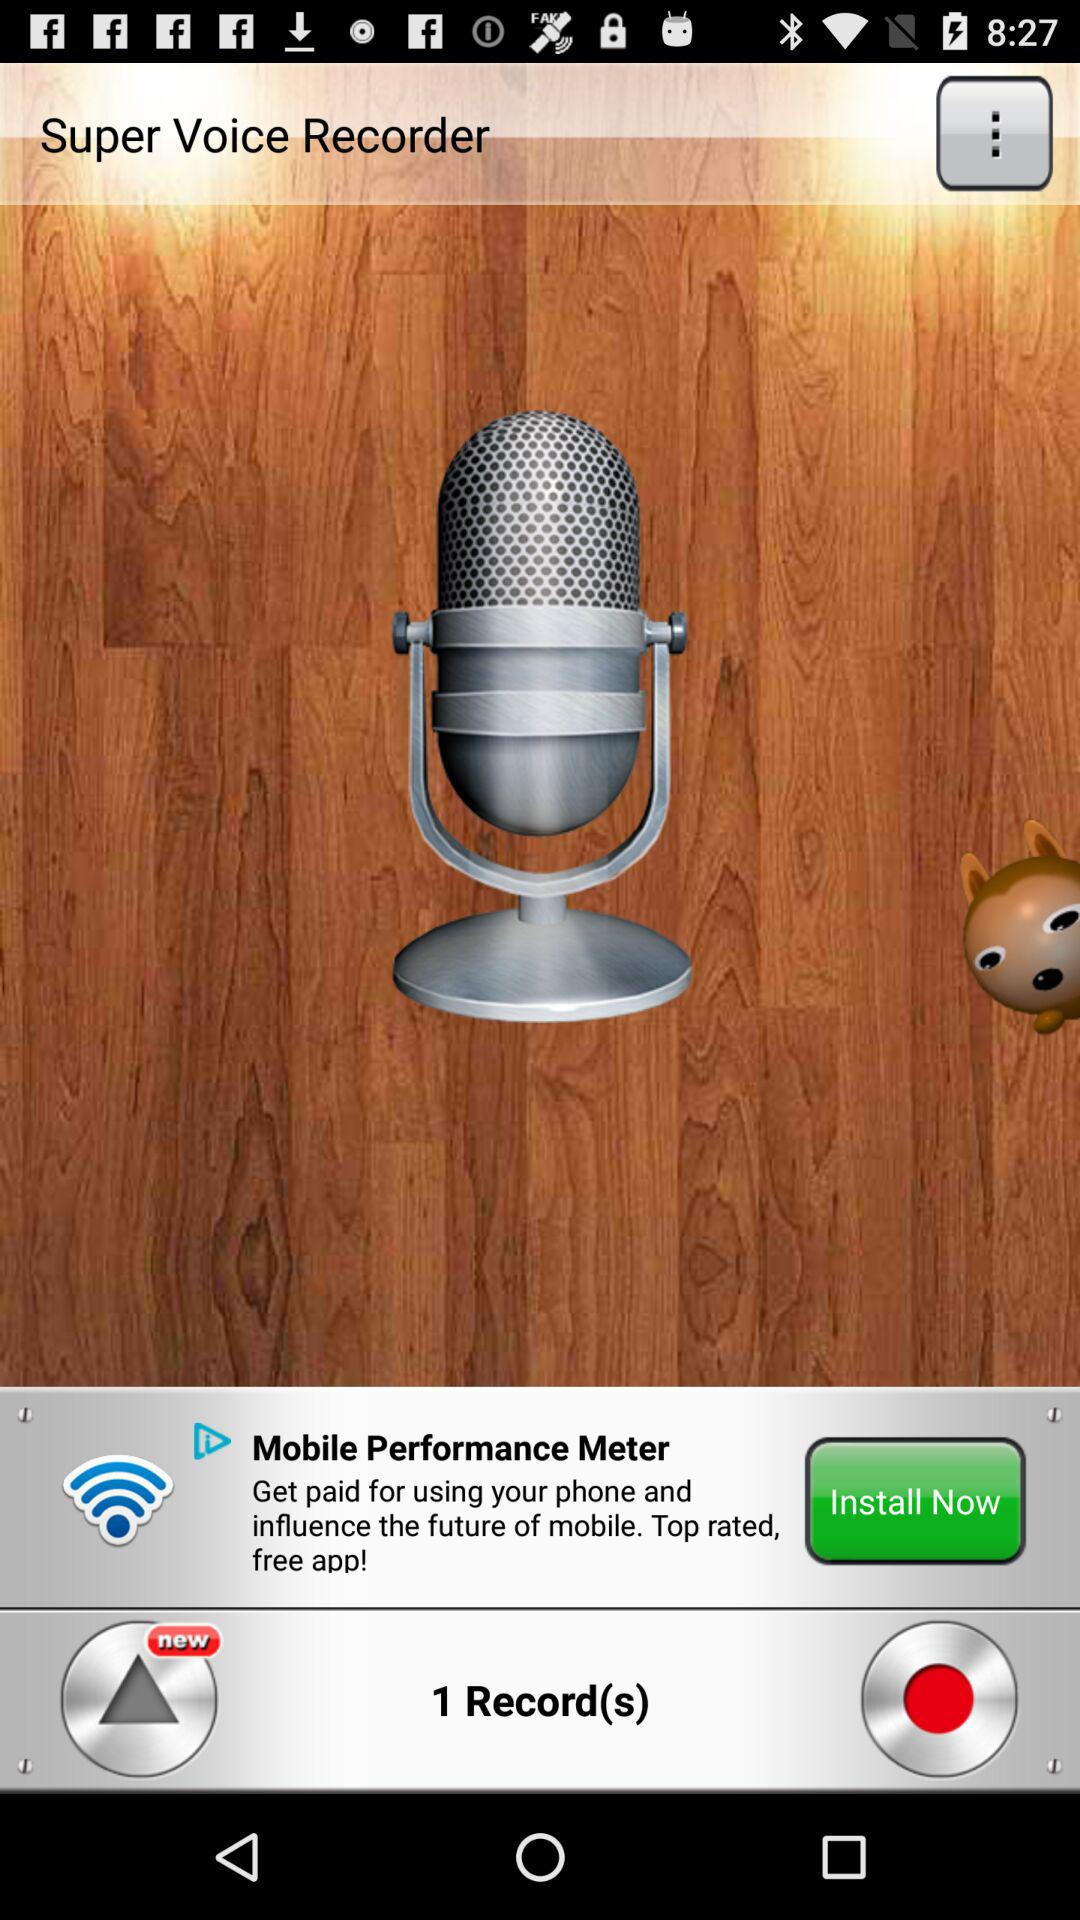How many recordings are there? There is 1 recording. 